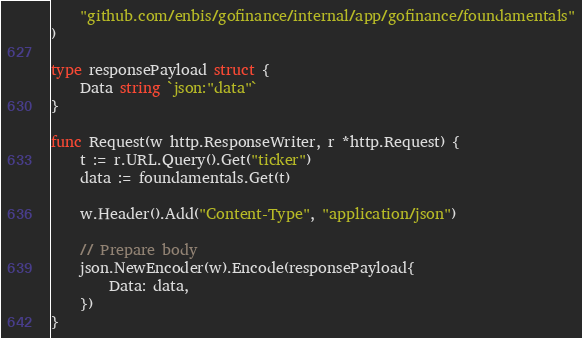Convert code to text. <code><loc_0><loc_0><loc_500><loc_500><_Go_>	"github.com/enbis/gofinance/internal/app/gofinance/foundamentals"
)

type responsePayload struct {
	Data string `json:"data"`
}

func Request(w http.ResponseWriter, r *http.Request) {
	t := r.URL.Query().Get("ticker")
	data := foundamentals.Get(t)

	w.Header().Add("Content-Type", "application/json")

	// Prepare body
	json.NewEncoder(w).Encode(responsePayload{
		Data: data,
	})
}
</code> 